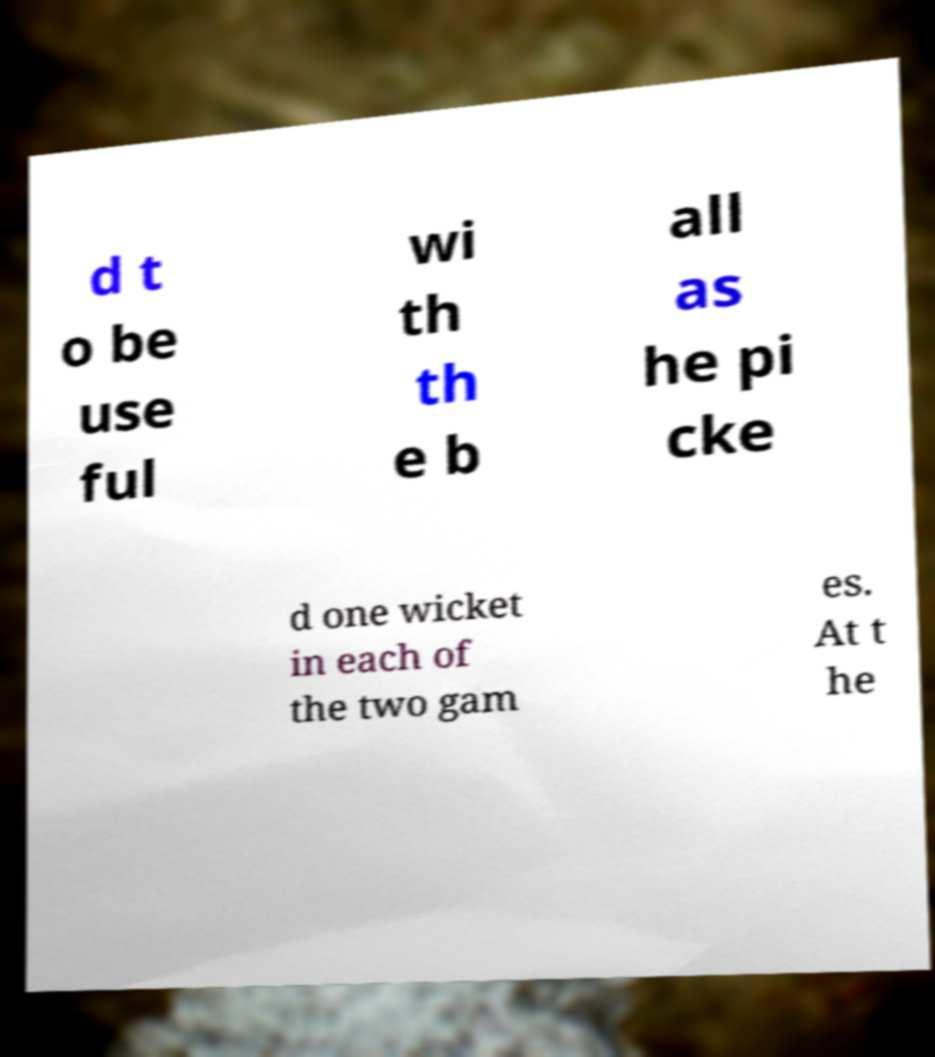Could you extract and type out the text from this image? d t o be use ful wi th th e b all as he pi cke d one wicket in each of the two gam es. At t he 